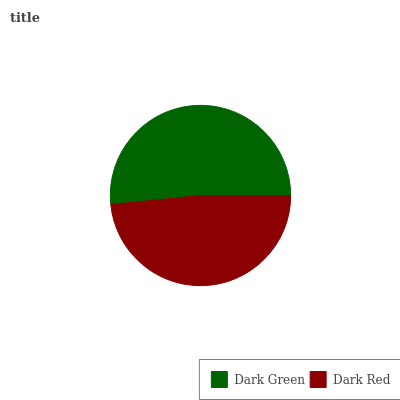Is Dark Red the minimum?
Answer yes or no. Yes. Is Dark Green the maximum?
Answer yes or no. Yes. Is Dark Red the maximum?
Answer yes or no. No. Is Dark Green greater than Dark Red?
Answer yes or no. Yes. Is Dark Red less than Dark Green?
Answer yes or no. Yes. Is Dark Red greater than Dark Green?
Answer yes or no. No. Is Dark Green less than Dark Red?
Answer yes or no. No. Is Dark Green the high median?
Answer yes or no. Yes. Is Dark Red the low median?
Answer yes or no. Yes. Is Dark Red the high median?
Answer yes or no. No. Is Dark Green the low median?
Answer yes or no. No. 